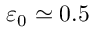Convert formula to latex. <formula><loc_0><loc_0><loc_500><loc_500>\varepsilon _ { 0 } \simeq 0 . 5</formula> 